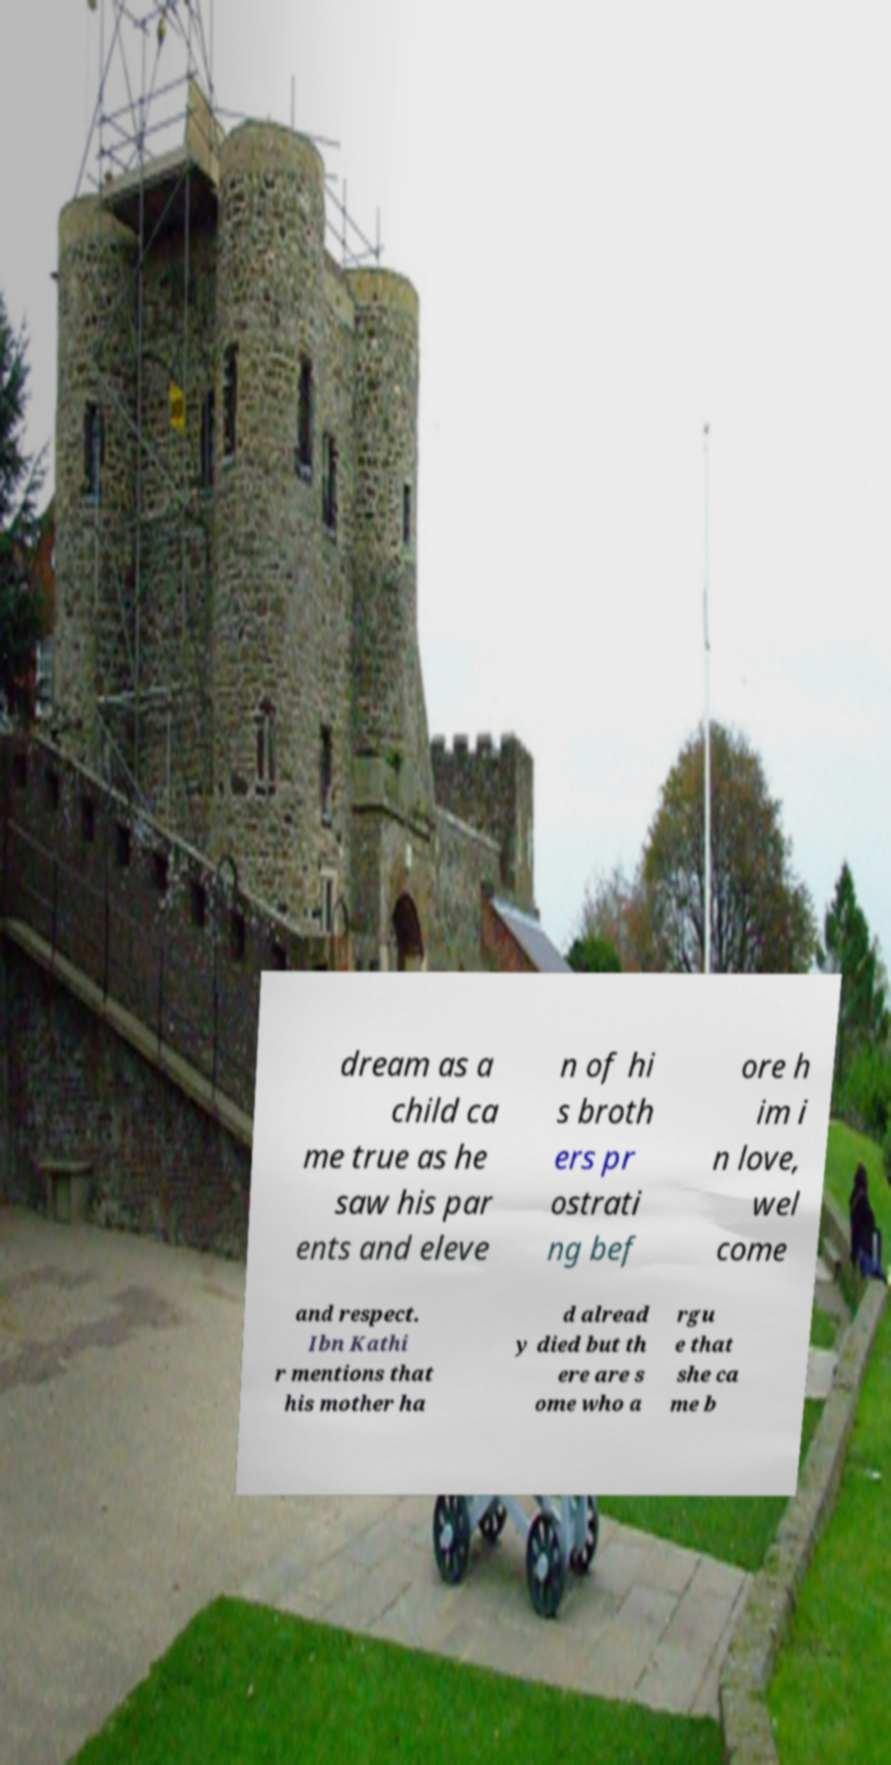Please identify and transcribe the text found in this image. dream as a child ca me true as he saw his par ents and eleve n of hi s broth ers pr ostrati ng bef ore h im i n love, wel come and respect. Ibn Kathi r mentions that his mother ha d alread y died but th ere are s ome who a rgu e that she ca me b 